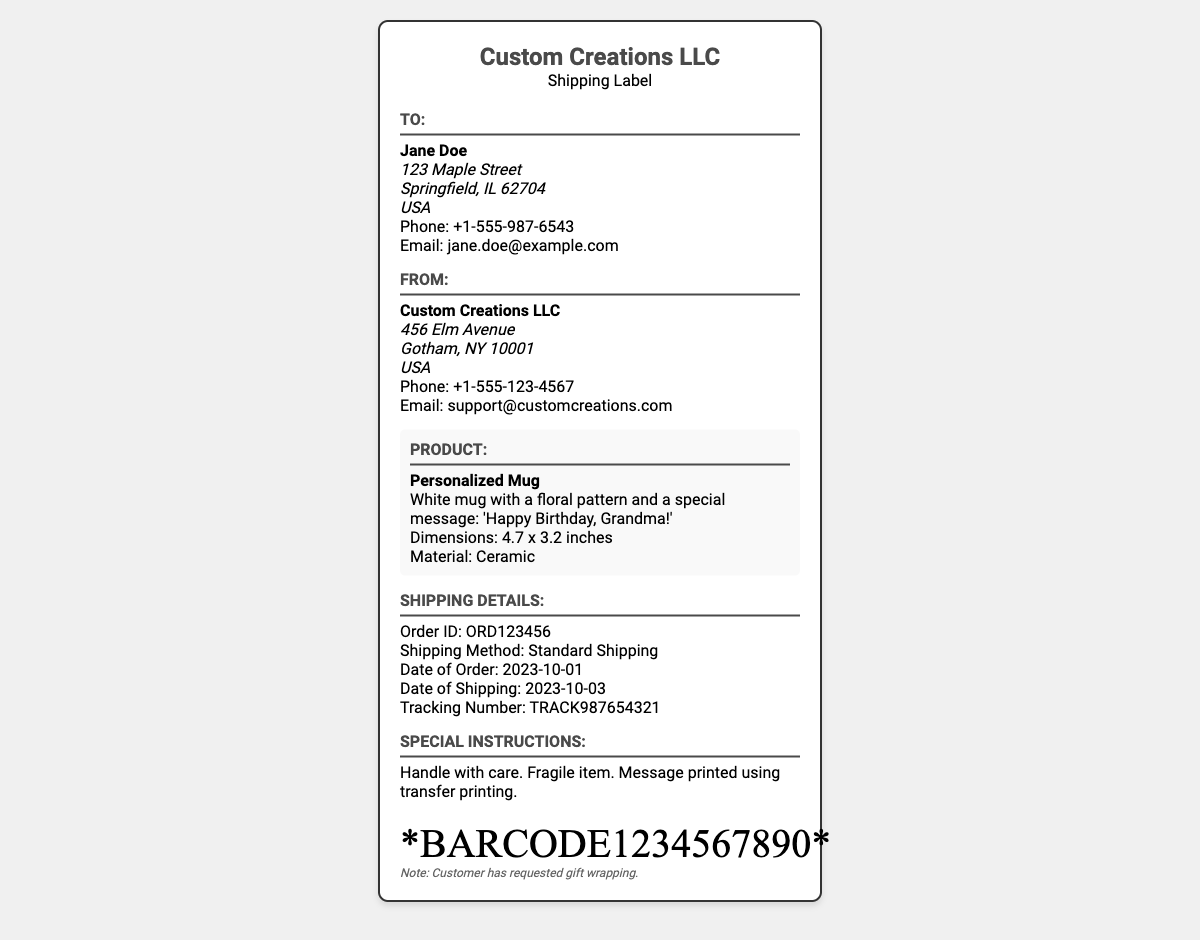What is the recipient's name? The document specifies the recipient's name in the "To:" section, which is directly stated.
Answer: Jane Doe What is the shipping method? The shipping method is mentioned in the "Shipping Details" section with a clear label.
Answer: Standard Shipping What is the order ID? The order ID is noted in the "Shipping Details" section for tracking purposes.
Answer: ORD123456 What is the product being shipped? The product is described in the "Product" section, identifying the item being shipped.
Answer: Personalized Mug When was the order placed? The date the order was made is clearly stated in the "Shipping Details" section, allowing for retrieval of this specific date.
Answer: 2023-10-01 Where is the sender located? The address of the sender is detailed in the "From:" section and can be found quickly.
Answer: 456 Elm Avenue, Gotham, NY 10001, USA What special message is on the mug? The special message for the mug is provided in the "Product" section, detailing what is printed on it.
Answer: 'Happy Birthday, Grandma!' What precautions are mentioned for the shipping? Specific instructions for handling the package are outlined in the "Special Instructions" section.
Answer: Handle with care What is the tracking number? The tracking number is provided in the "Shipping Details" section for tracking the shipment's progress.
Answer: TRACK987654321 What is the customer's phone number? The customer's contact information is directly referenced in the "To:" section of the document.
Answer: +1-555-987-6543 